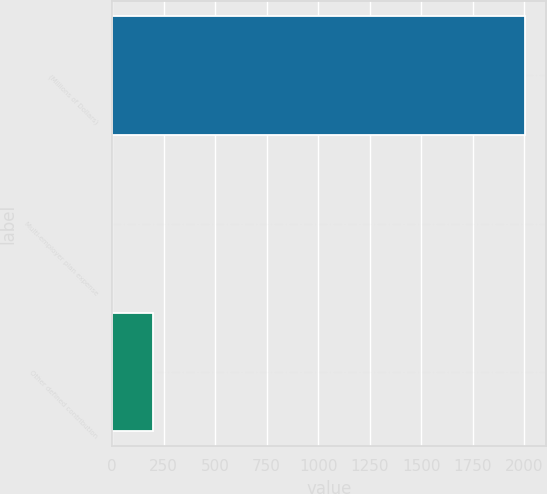<chart> <loc_0><loc_0><loc_500><loc_500><bar_chart><fcel>(Millions of Dollars)<fcel>Multi-employer plan expense<fcel>Other defined contribution<nl><fcel>2005<fcel>0.7<fcel>201.13<nl></chart> 